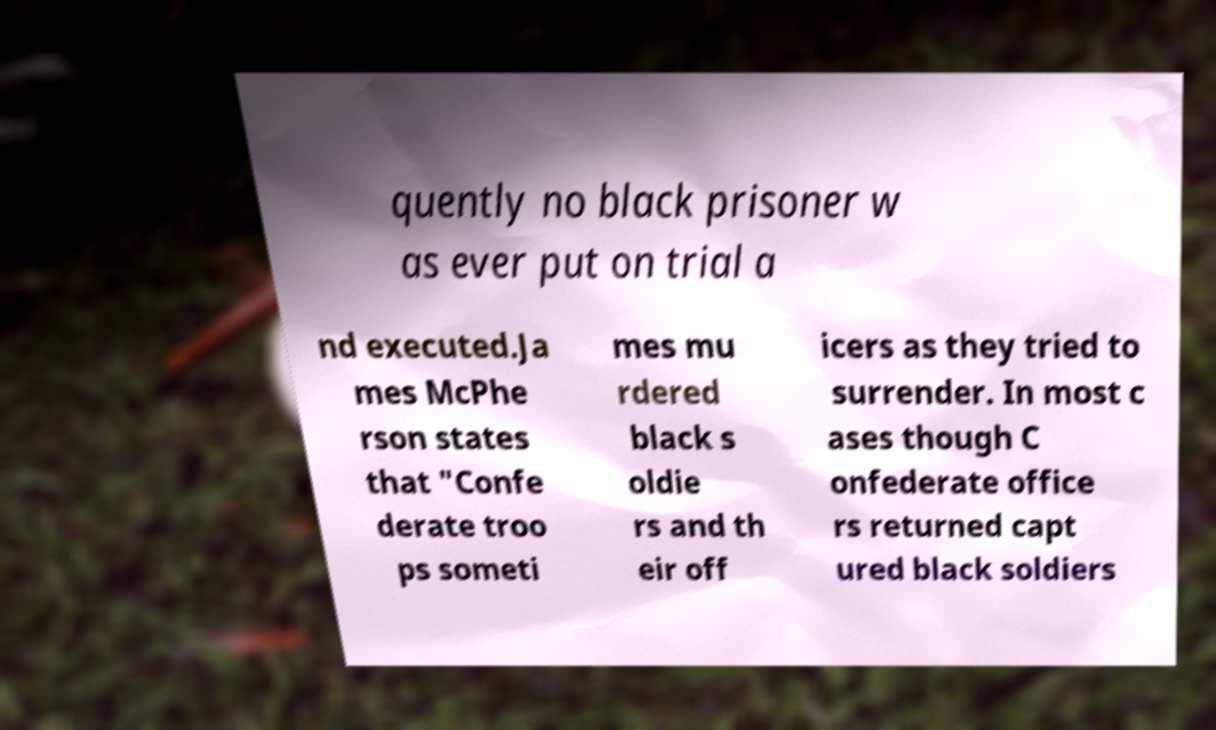There's text embedded in this image that I need extracted. Can you transcribe it verbatim? quently no black prisoner w as ever put on trial a nd executed.Ja mes McPhe rson states that "Confe derate troo ps someti mes mu rdered black s oldie rs and th eir off icers as they tried to surrender. In most c ases though C onfederate office rs returned capt ured black soldiers 